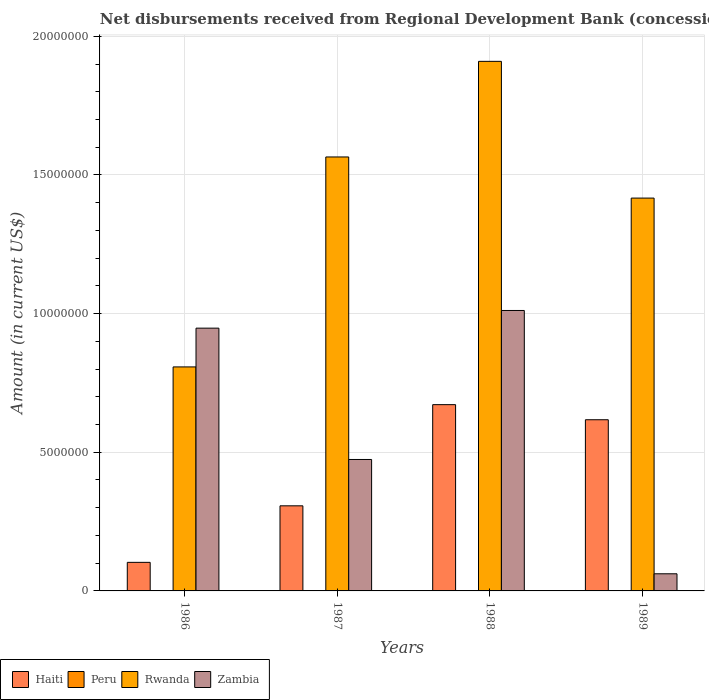How many different coloured bars are there?
Your answer should be compact. 3. How many bars are there on the 3rd tick from the right?
Offer a terse response. 3. What is the label of the 2nd group of bars from the left?
Provide a short and direct response. 1987. In how many cases, is the number of bars for a given year not equal to the number of legend labels?
Your answer should be compact. 4. What is the amount of disbursements received from Regional Development Bank in Zambia in 1987?
Keep it short and to the point. 4.74e+06. Across all years, what is the maximum amount of disbursements received from Regional Development Bank in Haiti?
Ensure brevity in your answer.  6.72e+06. Across all years, what is the minimum amount of disbursements received from Regional Development Bank in Haiti?
Keep it short and to the point. 1.03e+06. What is the total amount of disbursements received from Regional Development Bank in Zambia in the graph?
Provide a succinct answer. 2.49e+07. What is the difference between the amount of disbursements received from Regional Development Bank in Haiti in 1986 and that in 1989?
Your answer should be very brief. -5.14e+06. What is the difference between the amount of disbursements received from Regional Development Bank in Zambia in 1986 and the amount of disbursements received from Regional Development Bank in Peru in 1988?
Keep it short and to the point. 9.48e+06. What is the average amount of disbursements received from Regional Development Bank in Rwanda per year?
Provide a short and direct response. 1.42e+07. In the year 1986, what is the difference between the amount of disbursements received from Regional Development Bank in Rwanda and amount of disbursements received from Regional Development Bank in Haiti?
Make the answer very short. 7.05e+06. What is the ratio of the amount of disbursements received from Regional Development Bank in Haiti in 1986 to that in 1989?
Ensure brevity in your answer.  0.17. Is the amount of disbursements received from Regional Development Bank in Zambia in 1986 less than that in 1987?
Provide a succinct answer. No. What is the difference between the highest and the second highest amount of disbursements received from Regional Development Bank in Zambia?
Ensure brevity in your answer.  6.37e+05. What is the difference between the highest and the lowest amount of disbursements received from Regional Development Bank in Zambia?
Offer a very short reply. 9.50e+06. In how many years, is the amount of disbursements received from Regional Development Bank in Peru greater than the average amount of disbursements received from Regional Development Bank in Peru taken over all years?
Offer a terse response. 0. Is the sum of the amount of disbursements received from Regional Development Bank in Rwanda in 1988 and 1989 greater than the maximum amount of disbursements received from Regional Development Bank in Zambia across all years?
Keep it short and to the point. Yes. Is it the case that in every year, the sum of the amount of disbursements received from Regional Development Bank in Haiti and amount of disbursements received from Regional Development Bank in Rwanda is greater than the sum of amount of disbursements received from Regional Development Bank in Peru and amount of disbursements received from Regional Development Bank in Zambia?
Keep it short and to the point. No. Is it the case that in every year, the sum of the amount of disbursements received from Regional Development Bank in Zambia and amount of disbursements received from Regional Development Bank in Haiti is greater than the amount of disbursements received from Regional Development Bank in Rwanda?
Ensure brevity in your answer.  No. Are all the bars in the graph horizontal?
Offer a very short reply. No. How many years are there in the graph?
Keep it short and to the point. 4. What is the difference between two consecutive major ticks on the Y-axis?
Your answer should be compact. 5.00e+06. How many legend labels are there?
Your response must be concise. 4. What is the title of the graph?
Your answer should be very brief. Net disbursements received from Regional Development Bank (concessional). What is the label or title of the Y-axis?
Give a very brief answer. Amount (in current US$). What is the Amount (in current US$) in Haiti in 1986?
Offer a very short reply. 1.03e+06. What is the Amount (in current US$) in Peru in 1986?
Your answer should be compact. 0. What is the Amount (in current US$) of Rwanda in 1986?
Offer a very short reply. 8.08e+06. What is the Amount (in current US$) in Zambia in 1986?
Offer a very short reply. 9.48e+06. What is the Amount (in current US$) of Haiti in 1987?
Keep it short and to the point. 3.07e+06. What is the Amount (in current US$) in Peru in 1987?
Offer a very short reply. 0. What is the Amount (in current US$) in Rwanda in 1987?
Your answer should be very brief. 1.56e+07. What is the Amount (in current US$) in Zambia in 1987?
Your answer should be very brief. 4.74e+06. What is the Amount (in current US$) in Haiti in 1988?
Your response must be concise. 6.72e+06. What is the Amount (in current US$) in Rwanda in 1988?
Provide a succinct answer. 1.91e+07. What is the Amount (in current US$) of Zambia in 1988?
Ensure brevity in your answer.  1.01e+07. What is the Amount (in current US$) in Haiti in 1989?
Your answer should be very brief. 6.17e+06. What is the Amount (in current US$) of Peru in 1989?
Your answer should be compact. 0. What is the Amount (in current US$) in Rwanda in 1989?
Offer a terse response. 1.42e+07. What is the Amount (in current US$) of Zambia in 1989?
Your answer should be compact. 6.18e+05. Across all years, what is the maximum Amount (in current US$) of Haiti?
Keep it short and to the point. 6.72e+06. Across all years, what is the maximum Amount (in current US$) in Rwanda?
Your answer should be compact. 1.91e+07. Across all years, what is the maximum Amount (in current US$) in Zambia?
Offer a very short reply. 1.01e+07. Across all years, what is the minimum Amount (in current US$) in Haiti?
Your response must be concise. 1.03e+06. Across all years, what is the minimum Amount (in current US$) of Rwanda?
Your answer should be very brief. 8.08e+06. Across all years, what is the minimum Amount (in current US$) of Zambia?
Your response must be concise. 6.18e+05. What is the total Amount (in current US$) in Haiti in the graph?
Give a very brief answer. 1.70e+07. What is the total Amount (in current US$) in Rwanda in the graph?
Make the answer very short. 5.70e+07. What is the total Amount (in current US$) of Zambia in the graph?
Offer a very short reply. 2.49e+07. What is the difference between the Amount (in current US$) of Haiti in 1986 and that in 1987?
Ensure brevity in your answer.  -2.04e+06. What is the difference between the Amount (in current US$) of Rwanda in 1986 and that in 1987?
Your response must be concise. -7.57e+06. What is the difference between the Amount (in current US$) of Zambia in 1986 and that in 1987?
Provide a short and direct response. 4.74e+06. What is the difference between the Amount (in current US$) of Haiti in 1986 and that in 1988?
Provide a succinct answer. -5.69e+06. What is the difference between the Amount (in current US$) in Rwanda in 1986 and that in 1988?
Your response must be concise. -1.10e+07. What is the difference between the Amount (in current US$) of Zambia in 1986 and that in 1988?
Ensure brevity in your answer.  -6.37e+05. What is the difference between the Amount (in current US$) in Haiti in 1986 and that in 1989?
Provide a succinct answer. -5.14e+06. What is the difference between the Amount (in current US$) in Rwanda in 1986 and that in 1989?
Your answer should be very brief. -6.09e+06. What is the difference between the Amount (in current US$) of Zambia in 1986 and that in 1989?
Your answer should be compact. 8.86e+06. What is the difference between the Amount (in current US$) of Haiti in 1987 and that in 1988?
Make the answer very short. -3.65e+06. What is the difference between the Amount (in current US$) of Rwanda in 1987 and that in 1988?
Keep it short and to the point. -3.45e+06. What is the difference between the Amount (in current US$) of Zambia in 1987 and that in 1988?
Give a very brief answer. -5.37e+06. What is the difference between the Amount (in current US$) of Haiti in 1987 and that in 1989?
Make the answer very short. -3.10e+06. What is the difference between the Amount (in current US$) of Rwanda in 1987 and that in 1989?
Give a very brief answer. 1.48e+06. What is the difference between the Amount (in current US$) of Zambia in 1987 and that in 1989?
Offer a very short reply. 4.12e+06. What is the difference between the Amount (in current US$) in Haiti in 1988 and that in 1989?
Keep it short and to the point. 5.44e+05. What is the difference between the Amount (in current US$) of Rwanda in 1988 and that in 1989?
Give a very brief answer. 4.93e+06. What is the difference between the Amount (in current US$) of Zambia in 1988 and that in 1989?
Provide a short and direct response. 9.50e+06. What is the difference between the Amount (in current US$) of Haiti in 1986 and the Amount (in current US$) of Rwanda in 1987?
Offer a terse response. -1.46e+07. What is the difference between the Amount (in current US$) in Haiti in 1986 and the Amount (in current US$) in Zambia in 1987?
Your response must be concise. -3.71e+06. What is the difference between the Amount (in current US$) in Rwanda in 1986 and the Amount (in current US$) in Zambia in 1987?
Make the answer very short. 3.34e+06. What is the difference between the Amount (in current US$) in Haiti in 1986 and the Amount (in current US$) in Rwanda in 1988?
Provide a short and direct response. -1.81e+07. What is the difference between the Amount (in current US$) in Haiti in 1986 and the Amount (in current US$) in Zambia in 1988?
Your response must be concise. -9.08e+06. What is the difference between the Amount (in current US$) in Rwanda in 1986 and the Amount (in current US$) in Zambia in 1988?
Offer a very short reply. -2.04e+06. What is the difference between the Amount (in current US$) of Haiti in 1986 and the Amount (in current US$) of Rwanda in 1989?
Your answer should be compact. -1.31e+07. What is the difference between the Amount (in current US$) in Haiti in 1986 and the Amount (in current US$) in Zambia in 1989?
Offer a very short reply. 4.12e+05. What is the difference between the Amount (in current US$) of Rwanda in 1986 and the Amount (in current US$) of Zambia in 1989?
Give a very brief answer. 7.46e+06. What is the difference between the Amount (in current US$) in Haiti in 1987 and the Amount (in current US$) in Rwanda in 1988?
Ensure brevity in your answer.  -1.60e+07. What is the difference between the Amount (in current US$) in Haiti in 1987 and the Amount (in current US$) in Zambia in 1988?
Your response must be concise. -7.04e+06. What is the difference between the Amount (in current US$) of Rwanda in 1987 and the Amount (in current US$) of Zambia in 1988?
Your response must be concise. 5.54e+06. What is the difference between the Amount (in current US$) in Haiti in 1987 and the Amount (in current US$) in Rwanda in 1989?
Your response must be concise. -1.11e+07. What is the difference between the Amount (in current US$) in Haiti in 1987 and the Amount (in current US$) in Zambia in 1989?
Your answer should be very brief. 2.45e+06. What is the difference between the Amount (in current US$) in Rwanda in 1987 and the Amount (in current US$) in Zambia in 1989?
Your response must be concise. 1.50e+07. What is the difference between the Amount (in current US$) of Haiti in 1988 and the Amount (in current US$) of Rwanda in 1989?
Give a very brief answer. -7.45e+06. What is the difference between the Amount (in current US$) of Haiti in 1988 and the Amount (in current US$) of Zambia in 1989?
Your answer should be very brief. 6.10e+06. What is the difference between the Amount (in current US$) in Rwanda in 1988 and the Amount (in current US$) in Zambia in 1989?
Ensure brevity in your answer.  1.85e+07. What is the average Amount (in current US$) in Haiti per year?
Provide a succinct answer. 4.25e+06. What is the average Amount (in current US$) of Peru per year?
Offer a terse response. 0. What is the average Amount (in current US$) of Rwanda per year?
Your answer should be very brief. 1.42e+07. What is the average Amount (in current US$) in Zambia per year?
Offer a terse response. 6.24e+06. In the year 1986, what is the difference between the Amount (in current US$) of Haiti and Amount (in current US$) of Rwanda?
Keep it short and to the point. -7.05e+06. In the year 1986, what is the difference between the Amount (in current US$) of Haiti and Amount (in current US$) of Zambia?
Offer a terse response. -8.45e+06. In the year 1986, what is the difference between the Amount (in current US$) in Rwanda and Amount (in current US$) in Zambia?
Ensure brevity in your answer.  -1.40e+06. In the year 1987, what is the difference between the Amount (in current US$) of Haiti and Amount (in current US$) of Rwanda?
Your answer should be very brief. -1.26e+07. In the year 1987, what is the difference between the Amount (in current US$) of Haiti and Amount (in current US$) of Zambia?
Provide a short and direct response. -1.67e+06. In the year 1987, what is the difference between the Amount (in current US$) of Rwanda and Amount (in current US$) of Zambia?
Keep it short and to the point. 1.09e+07. In the year 1988, what is the difference between the Amount (in current US$) in Haiti and Amount (in current US$) in Rwanda?
Offer a terse response. -1.24e+07. In the year 1988, what is the difference between the Amount (in current US$) in Haiti and Amount (in current US$) in Zambia?
Your response must be concise. -3.40e+06. In the year 1988, what is the difference between the Amount (in current US$) of Rwanda and Amount (in current US$) of Zambia?
Keep it short and to the point. 8.98e+06. In the year 1989, what is the difference between the Amount (in current US$) in Haiti and Amount (in current US$) in Rwanda?
Keep it short and to the point. -7.99e+06. In the year 1989, what is the difference between the Amount (in current US$) in Haiti and Amount (in current US$) in Zambia?
Keep it short and to the point. 5.56e+06. In the year 1989, what is the difference between the Amount (in current US$) of Rwanda and Amount (in current US$) of Zambia?
Ensure brevity in your answer.  1.35e+07. What is the ratio of the Amount (in current US$) in Haiti in 1986 to that in 1987?
Your response must be concise. 0.34. What is the ratio of the Amount (in current US$) of Rwanda in 1986 to that in 1987?
Make the answer very short. 0.52. What is the ratio of the Amount (in current US$) of Zambia in 1986 to that in 1987?
Provide a succinct answer. 2. What is the ratio of the Amount (in current US$) of Haiti in 1986 to that in 1988?
Provide a short and direct response. 0.15. What is the ratio of the Amount (in current US$) of Rwanda in 1986 to that in 1988?
Provide a succinct answer. 0.42. What is the ratio of the Amount (in current US$) of Zambia in 1986 to that in 1988?
Your response must be concise. 0.94. What is the ratio of the Amount (in current US$) in Haiti in 1986 to that in 1989?
Offer a terse response. 0.17. What is the ratio of the Amount (in current US$) of Rwanda in 1986 to that in 1989?
Provide a short and direct response. 0.57. What is the ratio of the Amount (in current US$) in Zambia in 1986 to that in 1989?
Offer a terse response. 15.33. What is the ratio of the Amount (in current US$) of Haiti in 1987 to that in 1988?
Your response must be concise. 0.46. What is the ratio of the Amount (in current US$) of Rwanda in 1987 to that in 1988?
Offer a terse response. 0.82. What is the ratio of the Amount (in current US$) in Zambia in 1987 to that in 1988?
Offer a terse response. 0.47. What is the ratio of the Amount (in current US$) of Haiti in 1987 to that in 1989?
Your answer should be compact. 0.5. What is the ratio of the Amount (in current US$) of Rwanda in 1987 to that in 1989?
Offer a very short reply. 1.1. What is the ratio of the Amount (in current US$) of Zambia in 1987 to that in 1989?
Offer a very short reply. 7.67. What is the ratio of the Amount (in current US$) in Haiti in 1988 to that in 1989?
Provide a succinct answer. 1.09. What is the ratio of the Amount (in current US$) of Rwanda in 1988 to that in 1989?
Provide a succinct answer. 1.35. What is the ratio of the Amount (in current US$) in Zambia in 1988 to that in 1989?
Provide a succinct answer. 16.36. What is the difference between the highest and the second highest Amount (in current US$) of Haiti?
Provide a succinct answer. 5.44e+05. What is the difference between the highest and the second highest Amount (in current US$) of Rwanda?
Provide a short and direct response. 3.45e+06. What is the difference between the highest and the second highest Amount (in current US$) in Zambia?
Your response must be concise. 6.37e+05. What is the difference between the highest and the lowest Amount (in current US$) in Haiti?
Offer a very short reply. 5.69e+06. What is the difference between the highest and the lowest Amount (in current US$) of Rwanda?
Offer a very short reply. 1.10e+07. What is the difference between the highest and the lowest Amount (in current US$) of Zambia?
Your answer should be compact. 9.50e+06. 